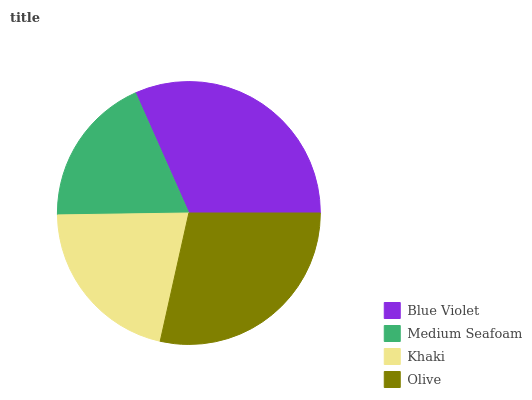Is Medium Seafoam the minimum?
Answer yes or no. Yes. Is Blue Violet the maximum?
Answer yes or no. Yes. Is Khaki the minimum?
Answer yes or no. No. Is Khaki the maximum?
Answer yes or no. No. Is Khaki greater than Medium Seafoam?
Answer yes or no. Yes. Is Medium Seafoam less than Khaki?
Answer yes or no. Yes. Is Medium Seafoam greater than Khaki?
Answer yes or no. No. Is Khaki less than Medium Seafoam?
Answer yes or no. No. Is Olive the high median?
Answer yes or no. Yes. Is Khaki the low median?
Answer yes or no. Yes. Is Khaki the high median?
Answer yes or no. No. Is Medium Seafoam the low median?
Answer yes or no. No. 